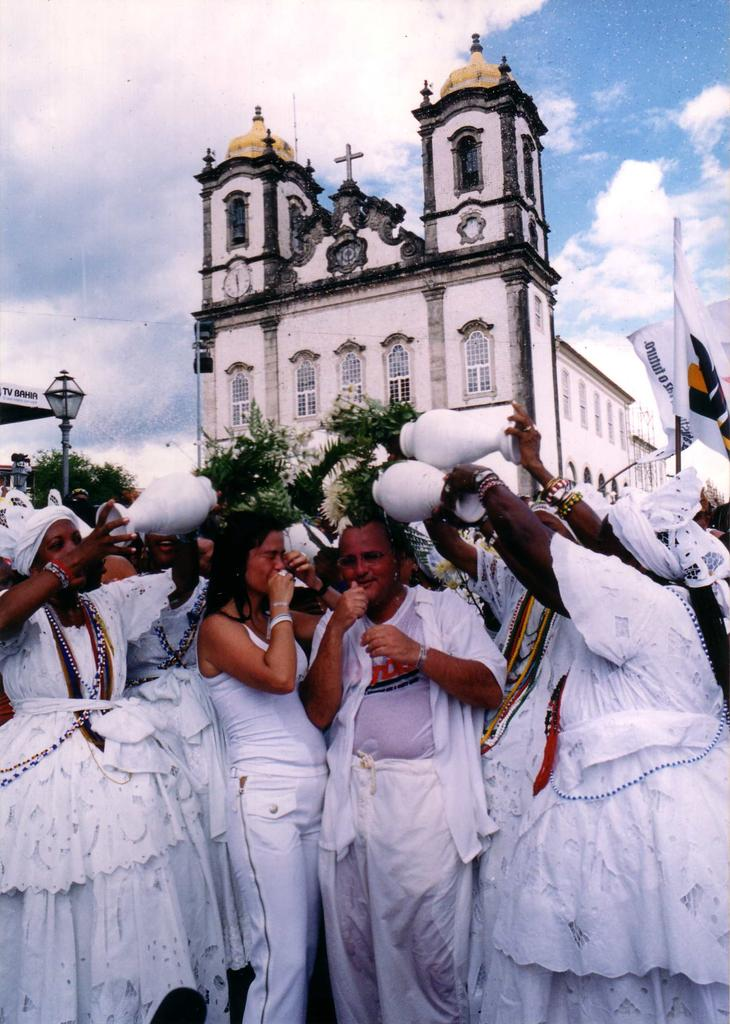What can be seen at the bottom of the image? There is a group of people at the bottom of the image. What are the people wearing? The people are wearing white color dresses. What structure is located at the top of the image? There appears to be a church at the top of the image. What is visible at the top of the image besides the church? The sky is visible at the top of the image. Can you tell me how many monkeys are sitting on the church roof in the image? There are no monkeys present in the image; it features a group of people wearing white dresses and a church. What type of apparel is the police officer wearing in the image? There is no police officer present in the image. 